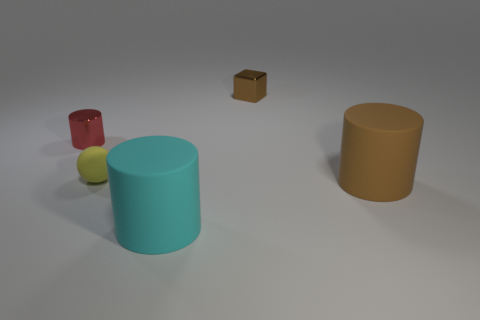There is a tiny metal object on the left side of the big cyan object; is its shape the same as the big brown rubber object?
Your response must be concise. Yes. What material is the large brown thing?
Offer a very short reply. Rubber. What is the shape of the object that is in front of the cylinder that is to the right of the small object to the right of the big cyan matte cylinder?
Offer a terse response. Cylinder. What number of other objects are the same shape as the small brown metal object?
Offer a very short reply. 0. There is a metallic block; is its color the same as the cylinder behind the big brown object?
Offer a terse response. No. How many small brown shiny things are there?
Ensure brevity in your answer.  1. How many things are either big cyan metal cylinders or rubber things?
Make the answer very short. 3. There is a matte cylinder that is the same color as the tiny block; what is its size?
Ensure brevity in your answer.  Large. There is a red metal object; are there any tiny brown shiny cubes to the left of it?
Keep it short and to the point. No. Are there more cylinders that are on the right side of the tiny shiny cylinder than cubes that are right of the brown metallic object?
Give a very brief answer. Yes. 